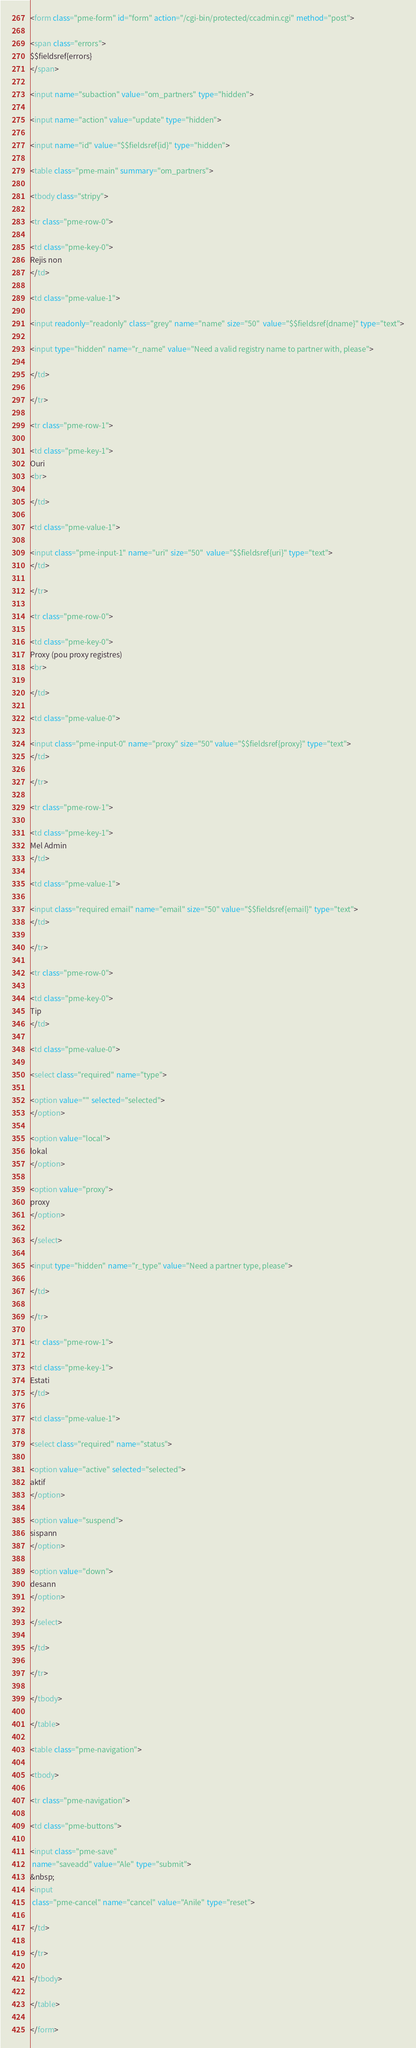<code> <loc_0><loc_0><loc_500><loc_500><_HTML_>
<form class="pme-form" id="form" action="/cgi-bin/protected/ccadmin.cgi" method="post">

<span class="errors">
$$fieldsref{errors}
</span>

<input name="subaction" value="om_partners" type="hidden">

<input name="action" value="update" type="hidden">

<input name="id" value="$$fieldsref{id}" type="hidden">

<table class="pme-main" summary="om_partners">

<tbody class="stripy">

<tr class="pme-row-0">

<td class="pme-key-0">
Rejis non
</td>

<td class="pme-value-1">

<input readonly="readonly" class="grey" name="name" size="50"  value="$$fieldsref{dname}" type="text">

<input type="hidden" name="r_name" value="Need a valid registry name to partner with, please">

</td>

</tr>

<tr class="pme-row-1">

<td class="pme-key-1">
Ouri
<br>

</td>

<td class="pme-value-1">

<input class="pme-input-1" name="uri" size="50"  value="$$fieldsref{uri}" type="text">
</td>

</tr>

<tr class="pme-row-0">

<td class="pme-key-0">
Proxy (pou proxy registres)
<br>

</td>

<td class="pme-value-0">

<input class="pme-input-0" name="proxy" size="50" value="$$fieldsref{proxy}" type="text">
</td>

</tr>

<tr class="pme-row-1">

<td class="pme-key-1">
Mel Admin
</td>

<td class="pme-value-1">

<input class="required email" name="email" size="50" value="$$fieldsref{email}" type="text">
</td>

</tr>

<tr class="pme-row-0">

<td class="pme-key-0">
Tip
</td>

<td class="pme-value-0">

<select class="required" name="type">

<option value="" selected="selected">
</option>

<option value="local">
lokal
</option>

<option value="proxy">
proxy
</option>

</select>

<input type="hidden" name="r_type" value="Need a partner type, please">

</td>

</tr>

<tr class="pme-row-1">

<td class="pme-key-1">
Estati
</td>

<td class="pme-value-1">

<select class="required" name="status">

<option value="active" selected="selected">
aktif
</option>

<option value="suspend">
sispann
</option>

<option value="down">
desann
</option>

</select>

</td>

</tr>

</tbody>

</table>

<table class="pme-navigation">

<tbody>

<tr class="pme-navigation">

<td class="pme-buttons">

<input class="pme-save"
 name="saveadd" value="Ale" type="submit">
&nbsp;
<input
 class="pme-cancel" name="cancel" value="Anile" type="reset">

</td>

</tr>

</tbody>

</table>

</form>
</code> 